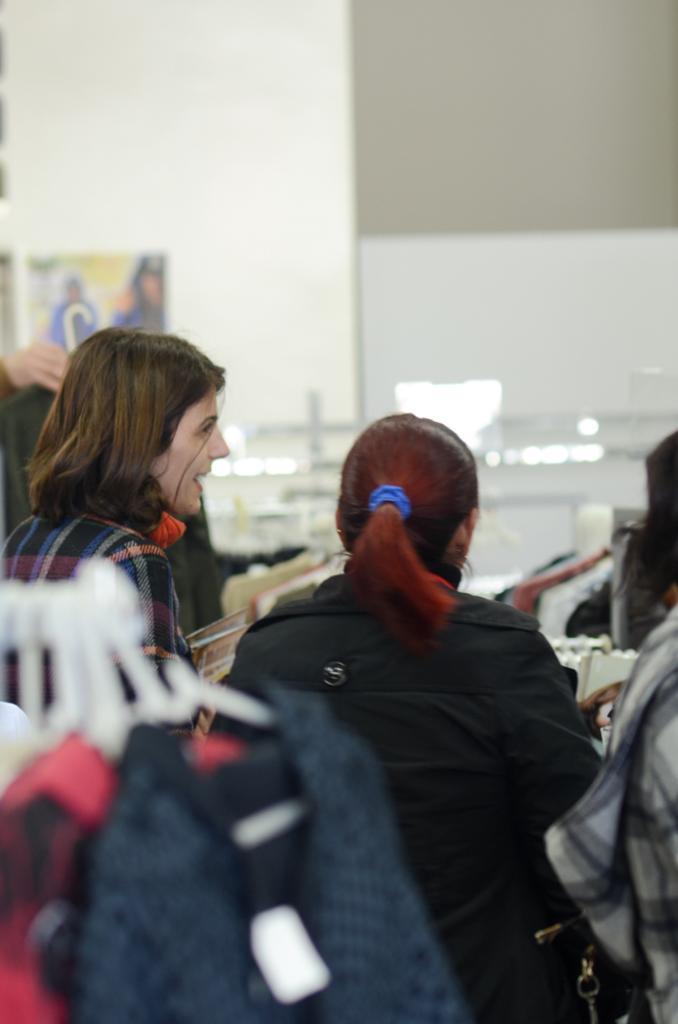Please provide a concise description of this image. Here we can see people and dresses. Poster is on the wall. 